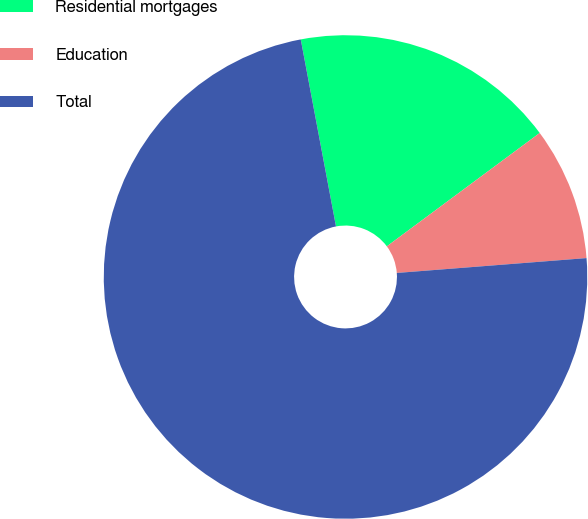Convert chart to OTSL. <chart><loc_0><loc_0><loc_500><loc_500><pie_chart><fcel>Residential mortgages<fcel>Education<fcel>Total<nl><fcel>17.81%<fcel>8.91%<fcel>73.28%<nl></chart> 